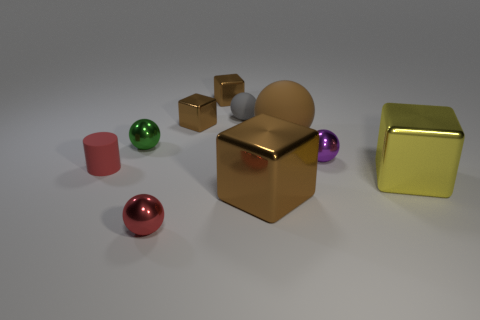There is a big object that is on the left side of the large rubber ball; does it have the same color as the large rubber sphere?
Your response must be concise. Yes. How many other objects are the same color as the tiny rubber ball?
Your answer should be compact. 0. What number of objects are either large purple matte things or gray things?
Offer a terse response. 1. How many objects are small red objects or cubes left of the gray object?
Offer a very short reply. 4. Are the purple ball and the large yellow thing made of the same material?
Ensure brevity in your answer.  Yes. What number of other things are the same material as the small red ball?
Your answer should be very brief. 6. Are there more yellow blocks than large green matte objects?
Your response must be concise. Yes. Do the big thing behind the small cylinder and the tiny purple thing have the same shape?
Your answer should be compact. Yes. Is the number of small metal things less than the number of small things?
Ensure brevity in your answer.  Yes. There is a gray sphere that is the same size as the cylinder; what is its material?
Provide a short and direct response. Rubber. 